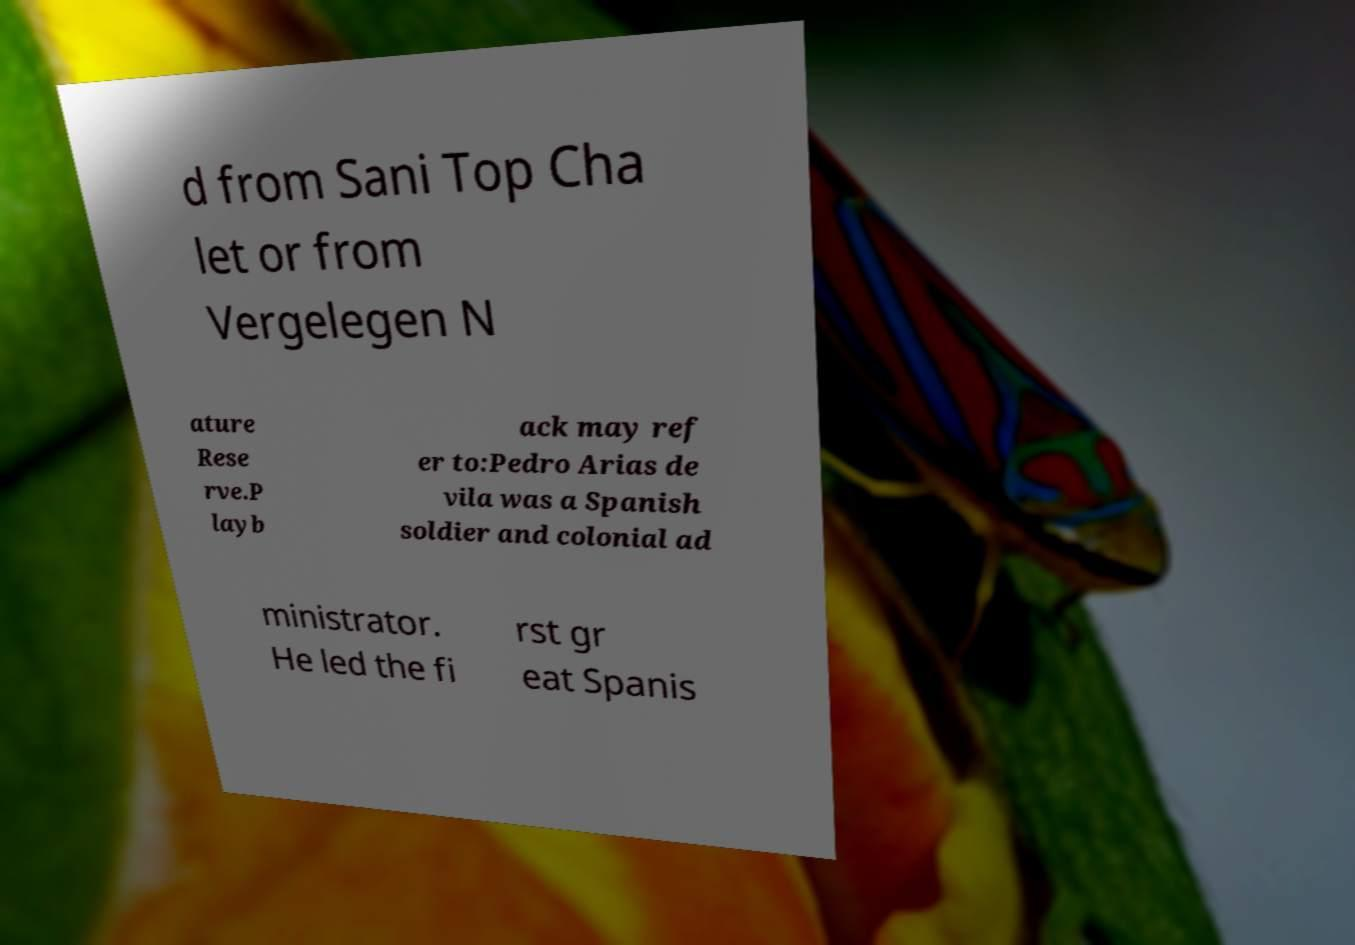What messages or text are displayed in this image? I need them in a readable, typed format. d from Sani Top Cha let or from Vergelegen N ature Rese rve.P layb ack may ref er to:Pedro Arias de vila was a Spanish soldier and colonial ad ministrator. He led the fi rst gr eat Spanis 